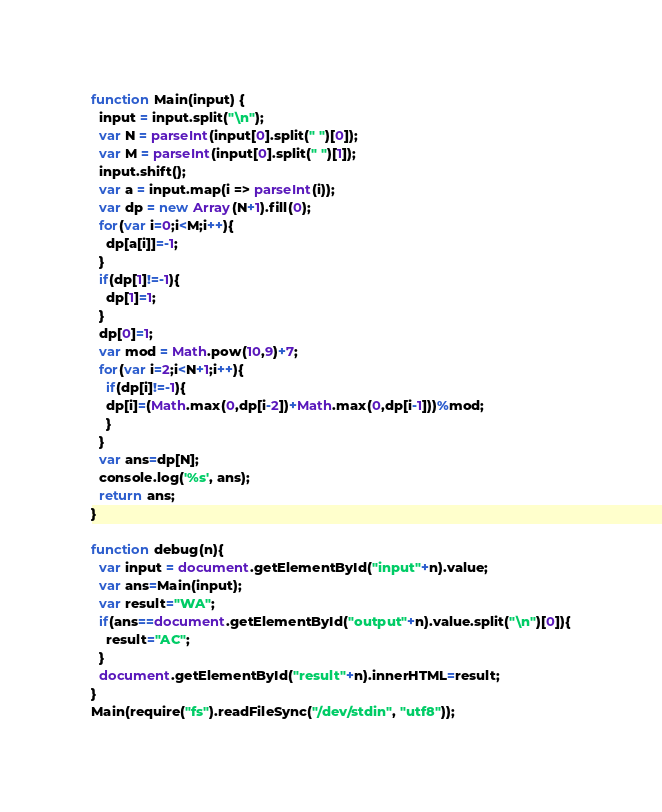<code> <loc_0><loc_0><loc_500><loc_500><_JavaScript_>

function Main(input) {
  input = input.split("\n");
  var N = parseInt(input[0].split(" ")[0]);
  var M = parseInt(input[0].split(" ")[1]);
  input.shift();
  var a = input.map(i => parseInt(i));
  var dp = new Array(N+1).fill(0);
  for(var i=0;i<M;i++){
    dp[a[i]]=-1;
  }
  if(dp[1]!=-1){
    dp[1]=1;
  }
  dp[0]=1;
  var mod = Math.pow(10,9)+7;
  for(var i=2;i<N+1;i++){
    if(dp[i]!=-1){
    dp[i]=(Math.max(0,dp[i-2])+Math.max(0,dp[i-1]))%mod;
    }
  }
  var ans=dp[N];
  console.log('%s', ans);
  return ans;
}

function debug(n){
  var input = document.getElementById("input"+n).value;
  var ans=Main(input);
  var result="WA";
  if(ans==document.getElementById("output"+n).value.split("\n")[0]){
    result="AC";
  }
  document.getElementById("result"+n).innerHTML=result;
}
Main(require("fs").readFileSync("/dev/stdin", "utf8"));</code> 